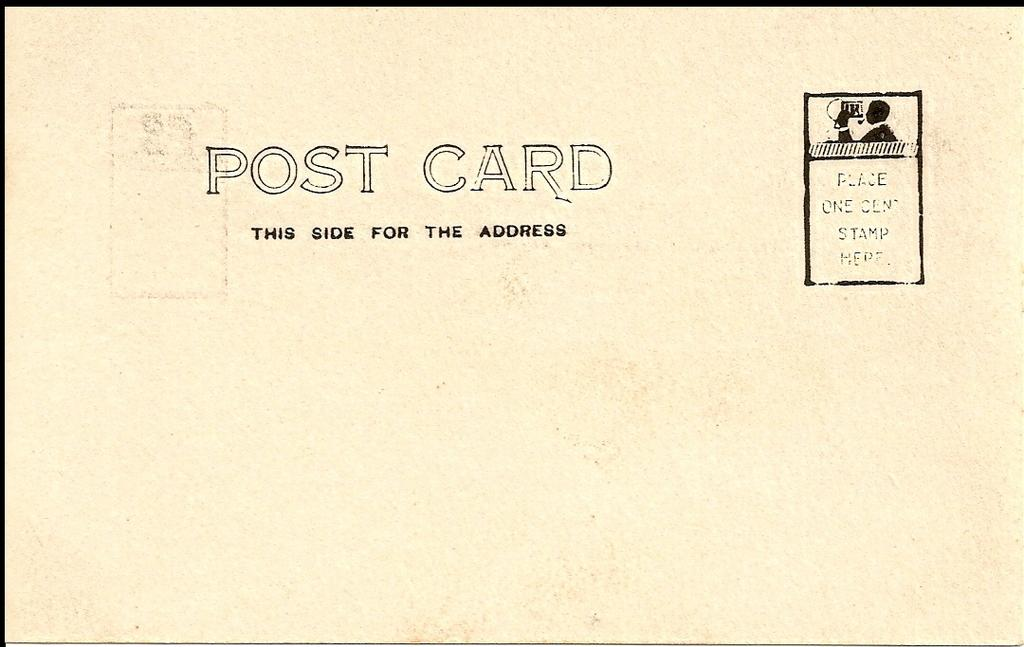<image>
Offer a succinct explanation of the picture presented. White and plain postcard that says "This Side for the Address". 